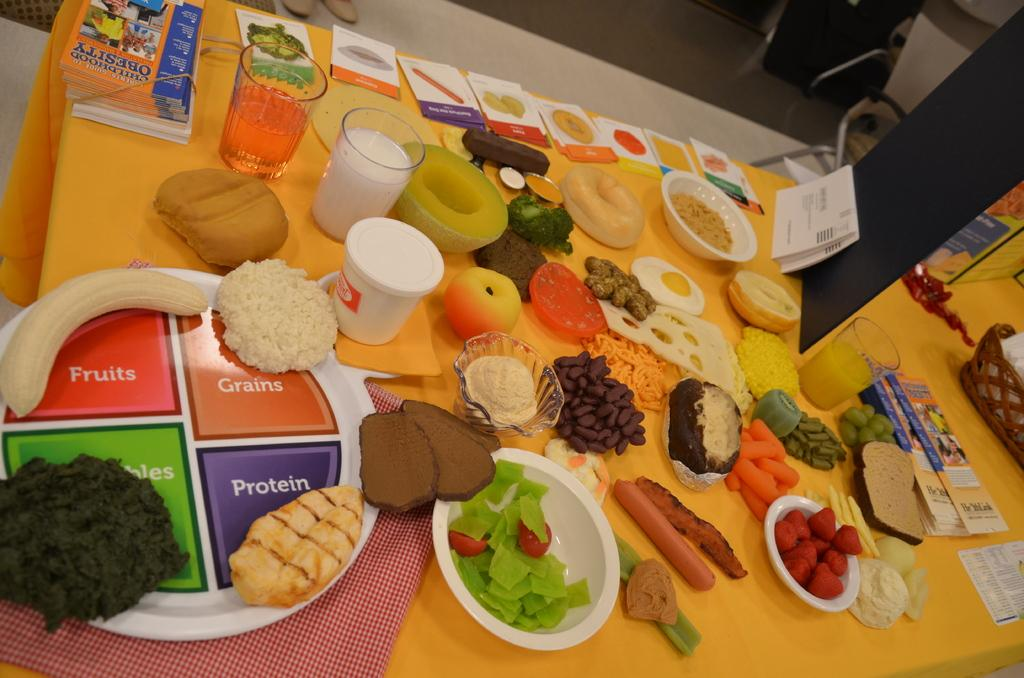What is the main piece of furniture in the image? There is a table in the image. What is covering the table? The table is covered with a cloth. What types of containers are on the table? There are glasses and bowls on the table. What else can be found on the table? There are papers and food items on the table. How many hills can be seen in the image? There are no hills present in the image. 